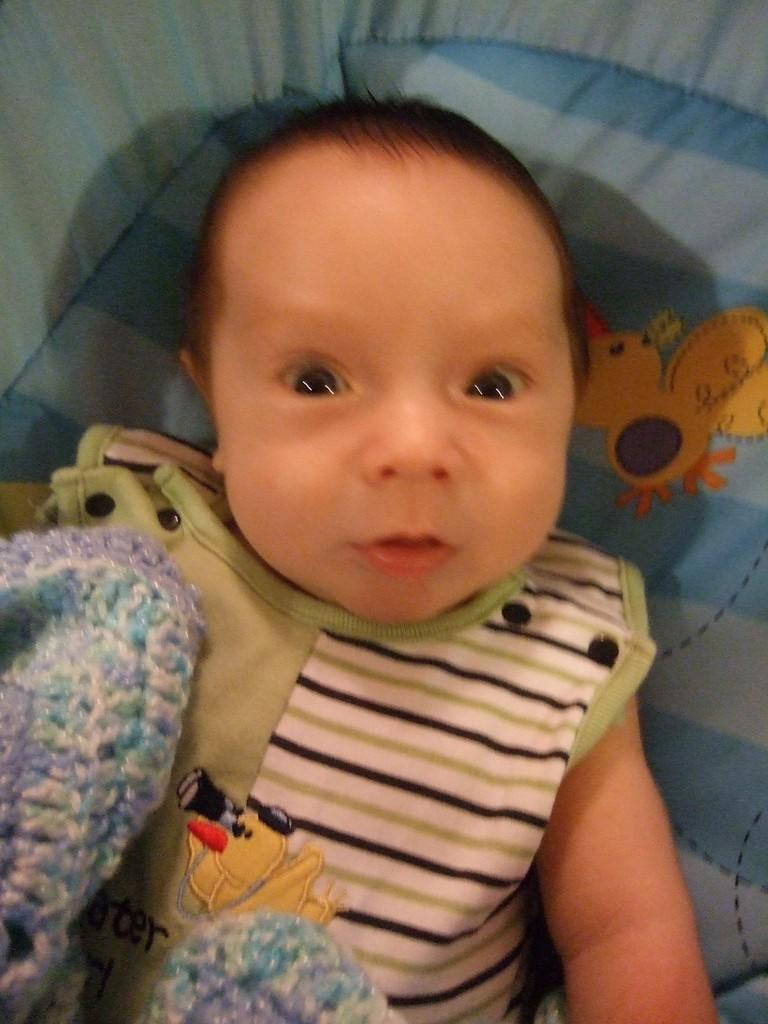What is the main subject of the image? There is a baby in the image. What is the baby wearing? The baby is wearing a green t-shirt. Where is the baby located in the image? The baby is laying on a blue color bed. What type of spade can be seen in the baby's hand in the image? There is no spade present in the image; the baby is laying on a blue color bed and wearing a green t-shirt. 